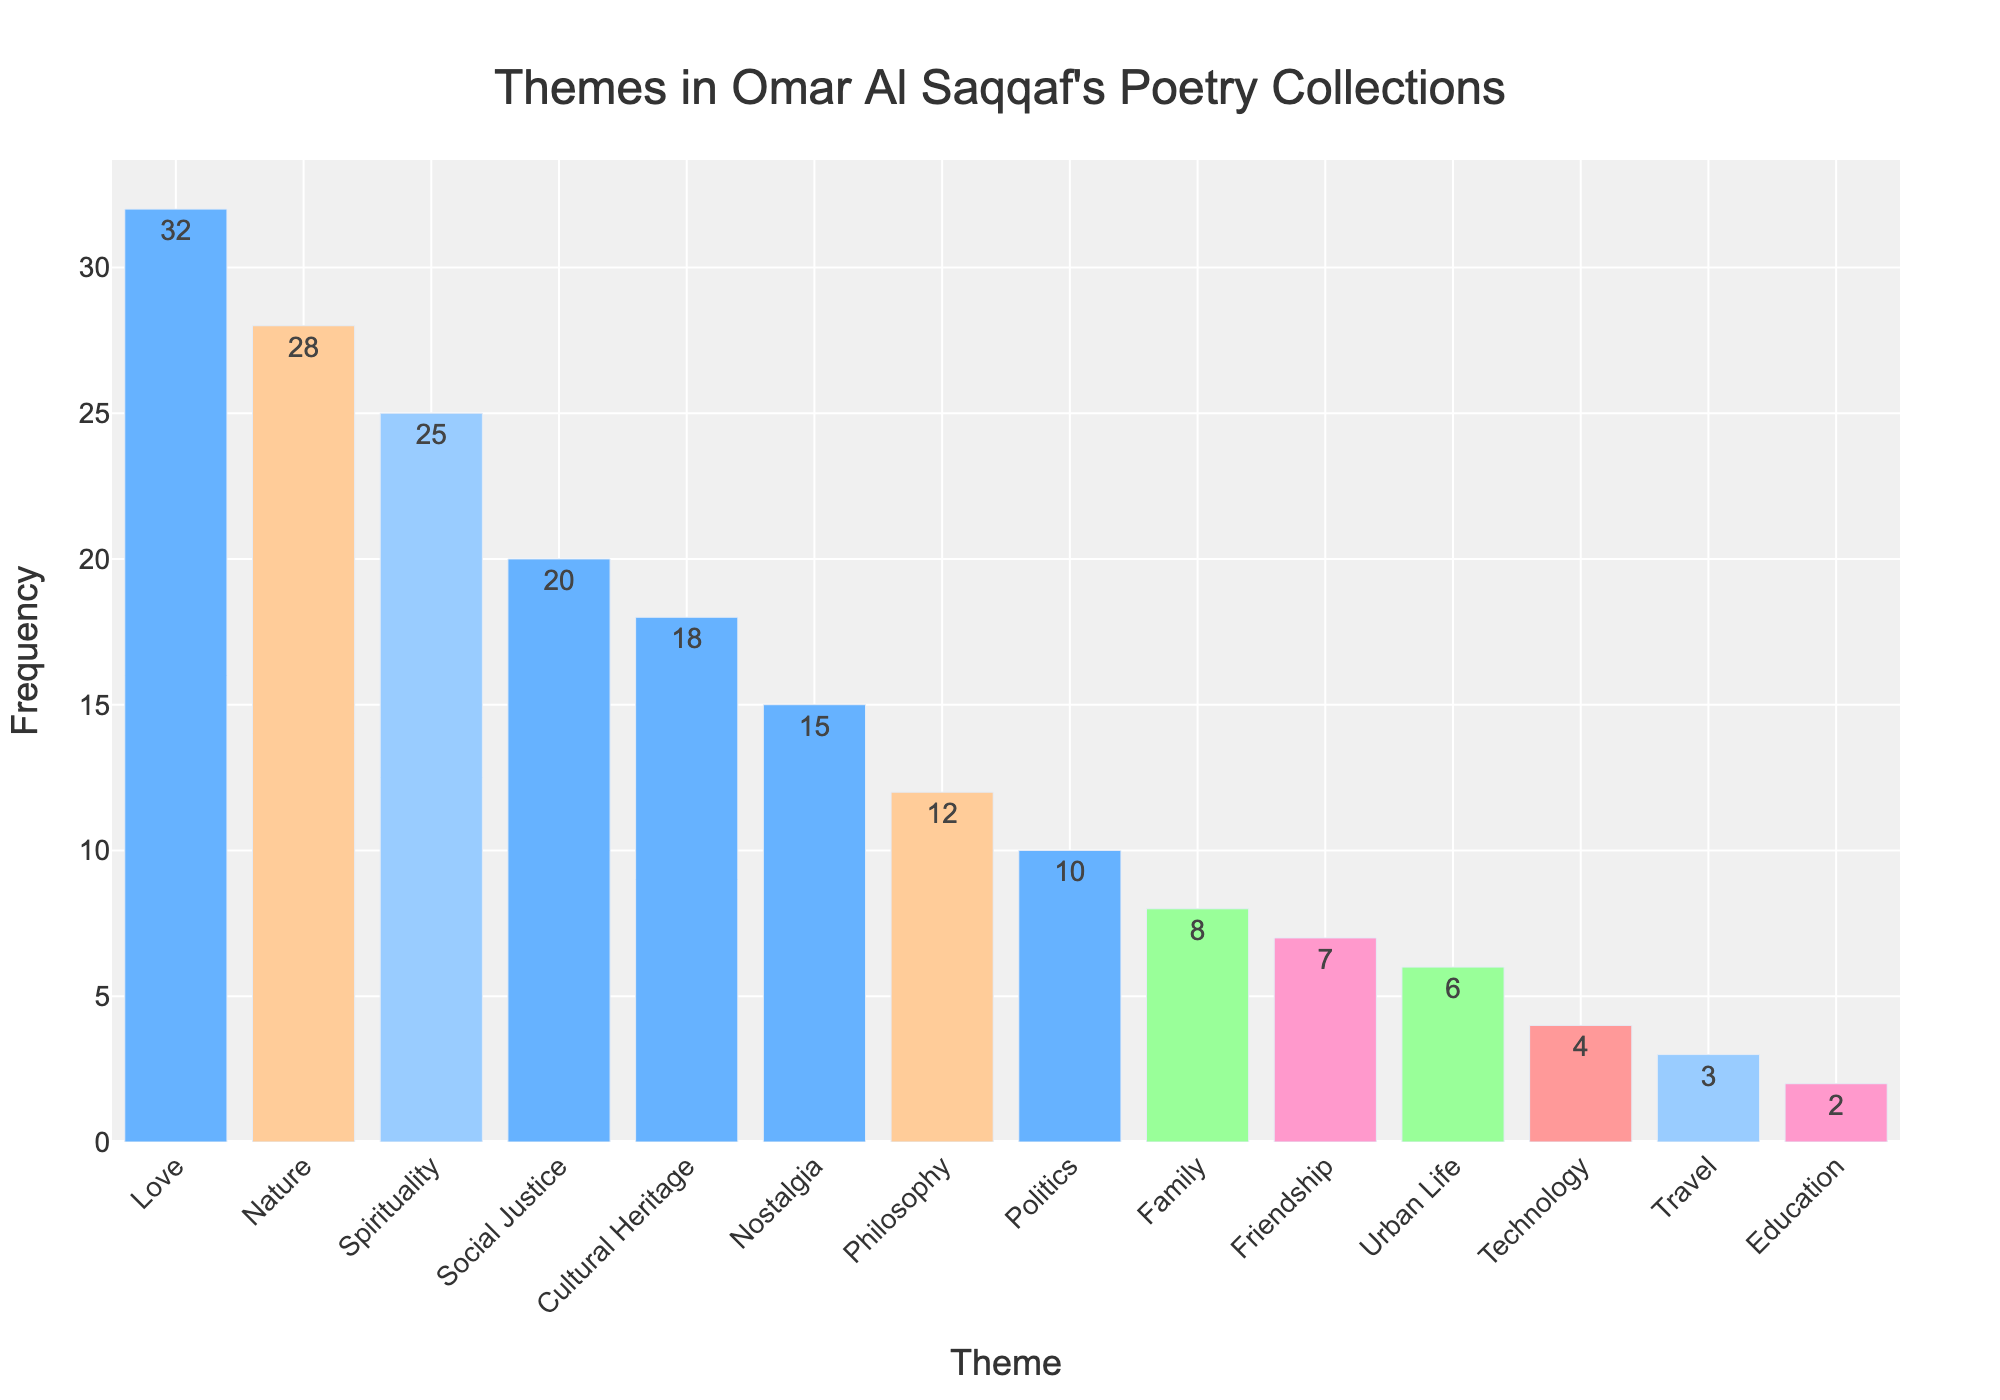Which theme is most frequently featured in Omar Al Saqqaf's poetry collections? By looking at the bar chart, the tallest bar represents the theme with the highest frequency. In this case, "Love" has the tallest bar.
Answer: Love Which two themes are equally represented in the middle range of frequencies? By examining the bars' heights and frequencies, both "Politics" and "Family" have frequencies close to the middle of the data set.
Answer: Politics and Family What is the combined frequency of "Love" and "Nature"? The frequency of "Love" is 32, and "Nature" is 28. Adding these together: 32 + 28 = 60.
Answer: 60 How many themes have a frequency greater than 15? By counting the bars that have heights above 15, the themes "Love", "Nature", "Spirituality", "Social Justice", and "Cultural Heritage" fit this criterion.
Answer: 5 What is the difference in frequency between the themes "Education" and "Travel"? The frequency for "Education" is 2, while "Travel" is 3. Subtracting these: 3 - 2 = 1.
Answer: 1 Which theme appears just less frequently than "Philosophy"? By looking at the height of the bar for "Philosophy", which is 12, the next shorter bar is for "Family" with a frequency of 8.
Answer: Family What is the average frequency of the top three themes? The top three themes by frequency are "Love" (32), "Nature" (28), and "Spirituality" (25). Adding these and dividing by three: (32 + 28 + 25) / 3 = 85 / 3 ≈ 28.33.
Answer: 28.33 How does the frequency of "Urban Life" compare to "Friendship"? By comparing the heights of their bars, "Friendship" has a frequency of 7, while "Urban Life" has a frequency of 6. Thus, "Friendship" is greater.
Answer: Friendship has a greater frequency What is the frequency of the least represented theme? The shortest bar represents the least frequent theme, which is "Education" with a frequency of 2.
Answer: 2 